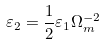Convert formula to latex. <formula><loc_0><loc_0><loc_500><loc_500>\varepsilon _ { 2 } = \frac { 1 } { 2 } \varepsilon _ { 1 } \Omega _ { m } ^ { - 2 }</formula> 